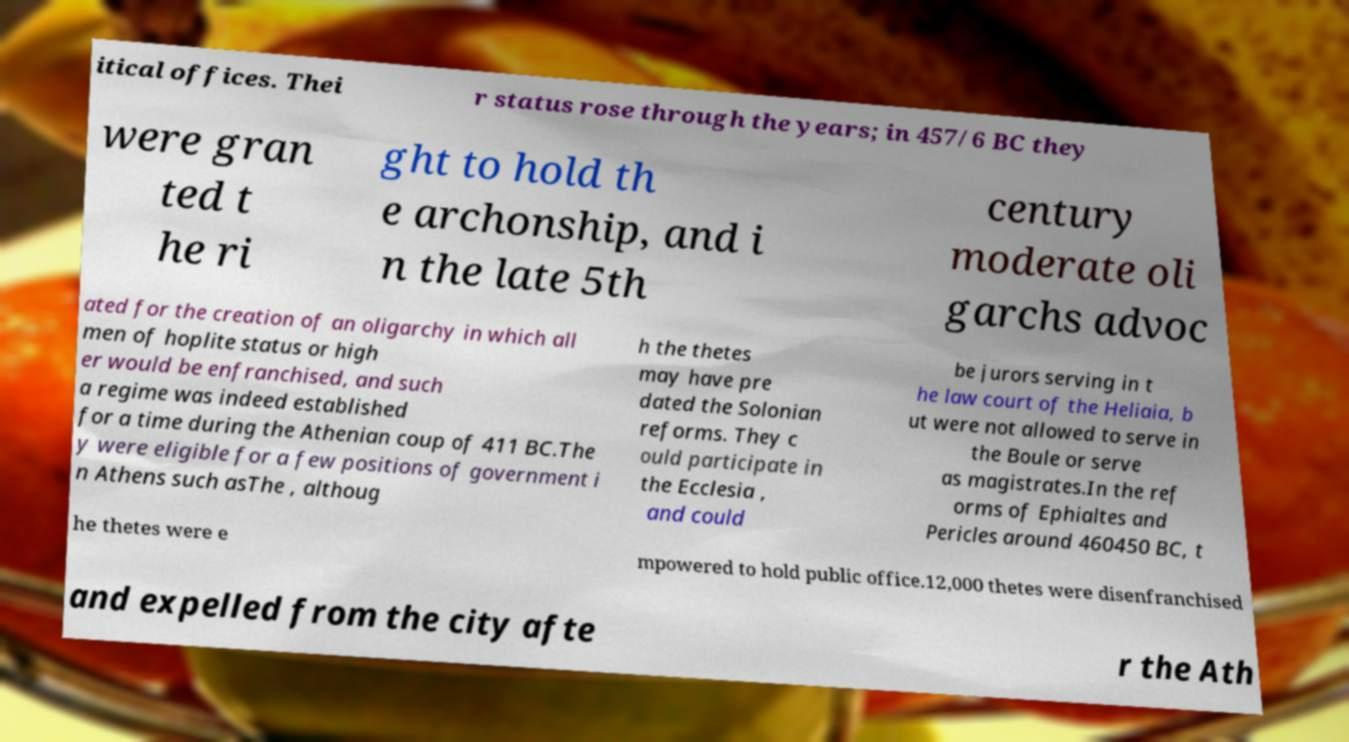Can you accurately transcribe the text from the provided image for me? itical offices. Thei r status rose through the years; in 457/6 BC they were gran ted t he ri ght to hold th e archonship, and i n the late 5th century moderate oli garchs advoc ated for the creation of an oligarchy in which all men of hoplite status or high er would be enfranchised, and such a regime was indeed established for a time during the Athenian coup of 411 BC.The y were eligible for a few positions of government i n Athens such asThe , althoug h the thetes may have pre dated the Solonian reforms. They c ould participate in the Ecclesia , and could be jurors serving in t he law court of the Heliaia, b ut were not allowed to serve in the Boule or serve as magistrates.In the ref orms of Ephialtes and Pericles around 460450 BC, t he thetes were e mpowered to hold public office.12,000 thetes were disenfranchised and expelled from the city afte r the Ath 